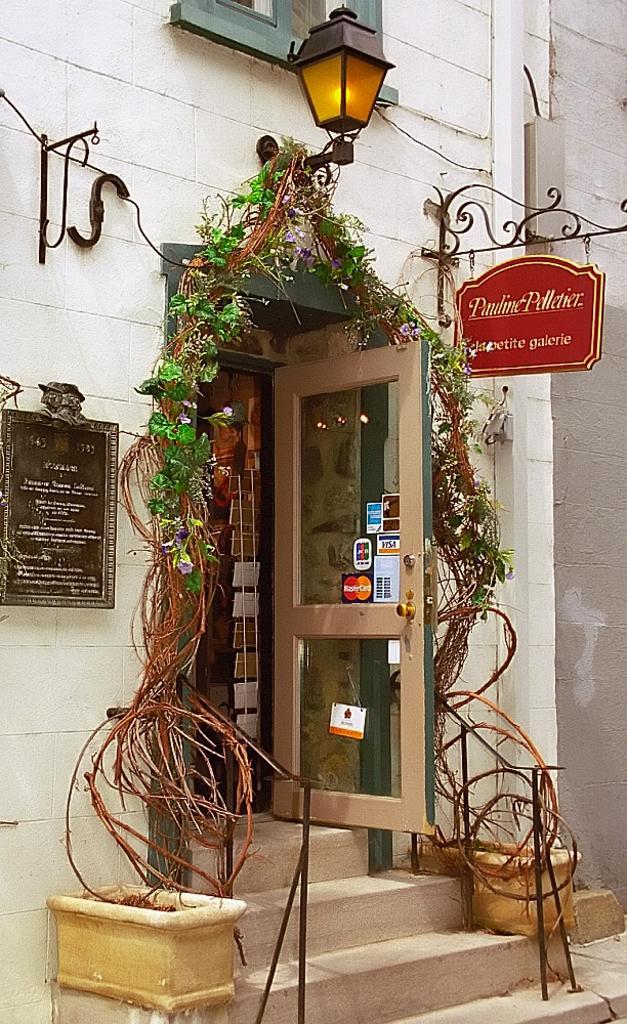Can you describe this image briefly? In this image we can see the entrance door, creeper running round it, street light, name boards and a window. 